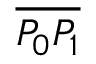Convert formula to latex. <formula><loc_0><loc_0><loc_500><loc_500>\overline { { P _ { 0 } P _ { 1 } } }</formula> 